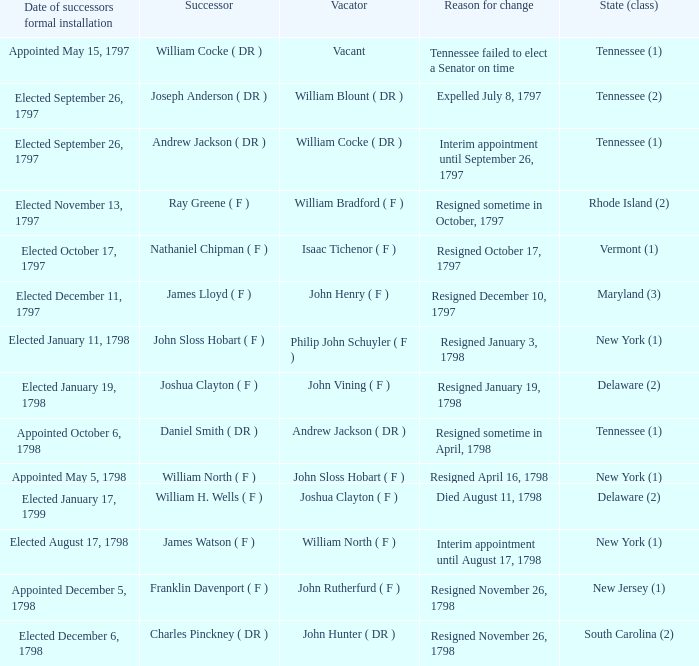What is the total number of dates of successor formal installation when the vacator was Joshua Clayton ( F )? 1.0. 